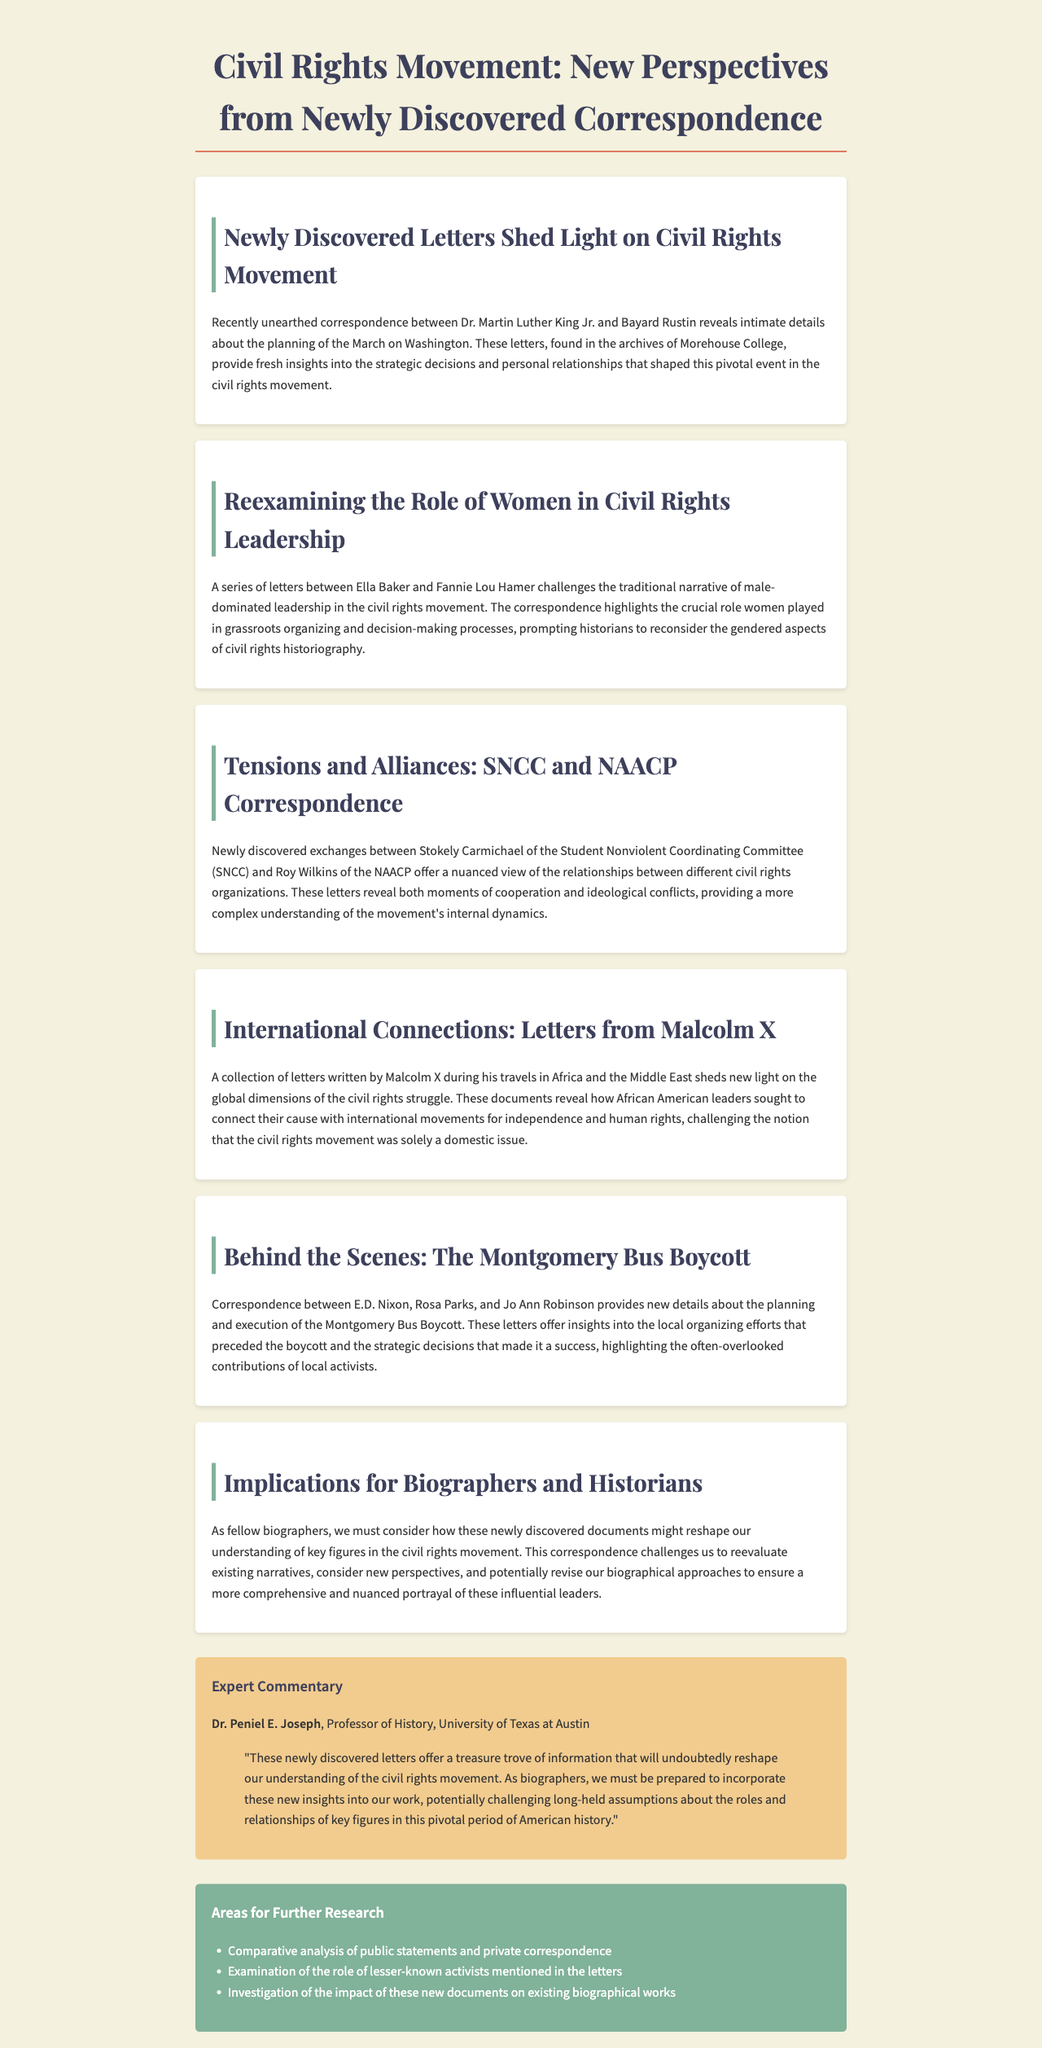What new correspondence was discovered? The newsletter mentions newly discovered letters between Dr. Martin Luther King Jr. and Bayard Rustin.
Answer: Letters between Dr. Martin Luther King Jr. and Bayard Rustin Who challenges the traditional narrative of leadership in the civil rights movement? The correspondence highlights the role of Ella Baker and Fannie Lou Hamer in leadership.
Answer: Ella Baker and Fannie Lou Hamer What organization did Stokely Carmichael belong to? The document states that Stokely Carmichael was part of the Student Nonviolent Coordinating Committee.
Answer: Student Nonviolent Coordinating Committee What significant event is discussed in relation to E.D. Nixon, Rosa Parks, and Jo Ann Robinson? The newsletter discusses the planning and execution of the Montgomery Bus Boycott involving these individuals.
Answer: Montgomery Bus Boycott What type of historical figures does the newsletter suggest re-evaluating? The document calls for a reevaluation of key figures in the civil rights movement.
Answer: Key figures Who provided expert commentary in the newsletter? The expert commentary is provided by Dr. Peniel E. Joseph.
Answer: Dr. Peniel E. Joseph What does the expert commentary suggest about the newly discovered letters? The commentary mentions that these letters will reshape our understanding of the civil rights movement.
Answer: Reshape understanding What area for further research is suggested? One suggested area for further research is the examination of lesser-known activists mentioned in the letters.
Answer: Examination of lesser-known activists 